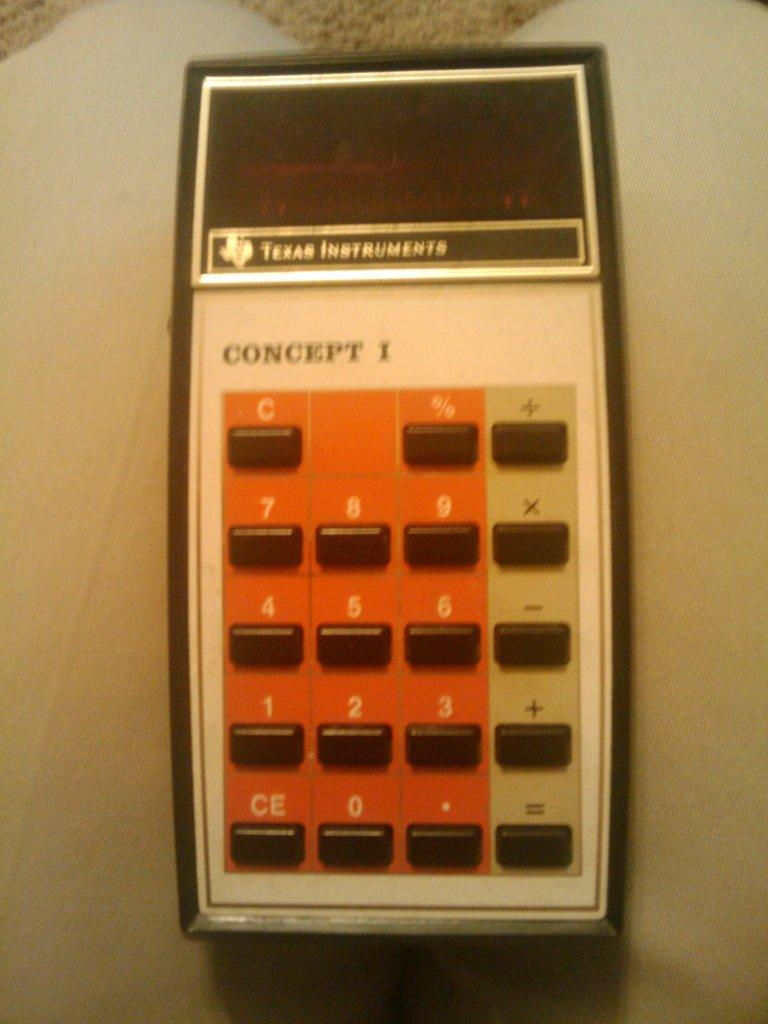Provide a one-sentence caption for the provided image. A Texas Instruments calculator is named Concept 1. 